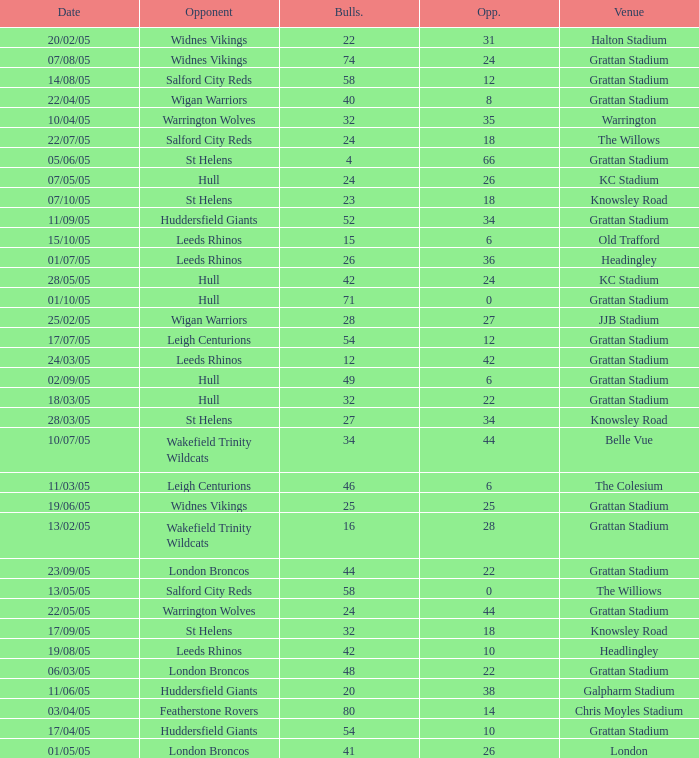What was the total number for the Bulls when they were at Old Trafford? 1.0. 